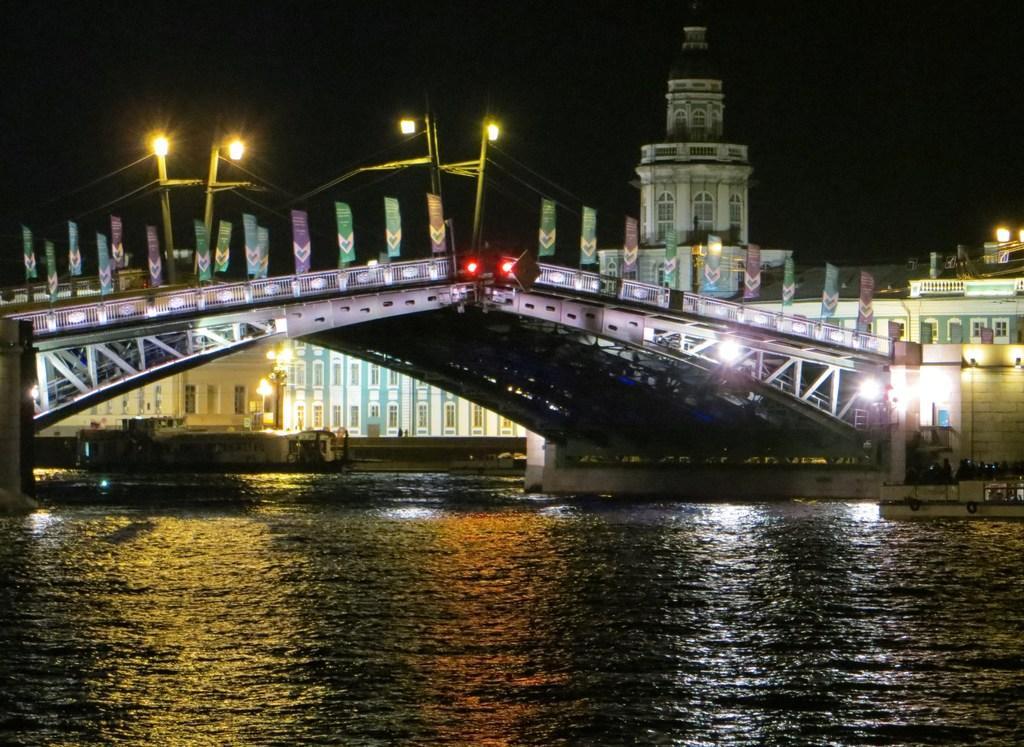How would you summarize this image in a sentence or two? There is a surface of water at the bottom of this image. We can see a bridge and a building in the middle of this image. There are lights at the top of this image. 